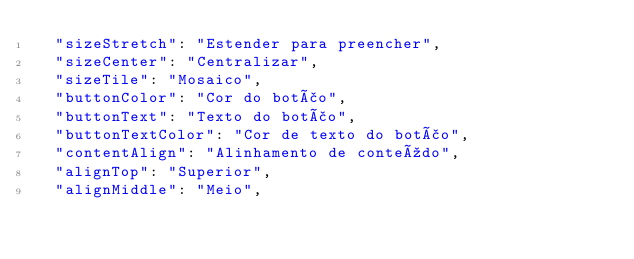Convert code to text. <code><loc_0><loc_0><loc_500><loc_500><_JavaScript_>  "sizeStretch": "Estender para preencher",
  "sizeCenter": "Centralizar",
  "sizeTile": "Mosaico",
  "buttonColor": "Cor do botão",
  "buttonText": "Texto do botão",
  "buttonTextColor": "Cor de texto do botão",
  "contentAlign": "Alinhamento de conteúdo",
  "alignTop": "Superior",
  "alignMiddle": "Meio",</code> 